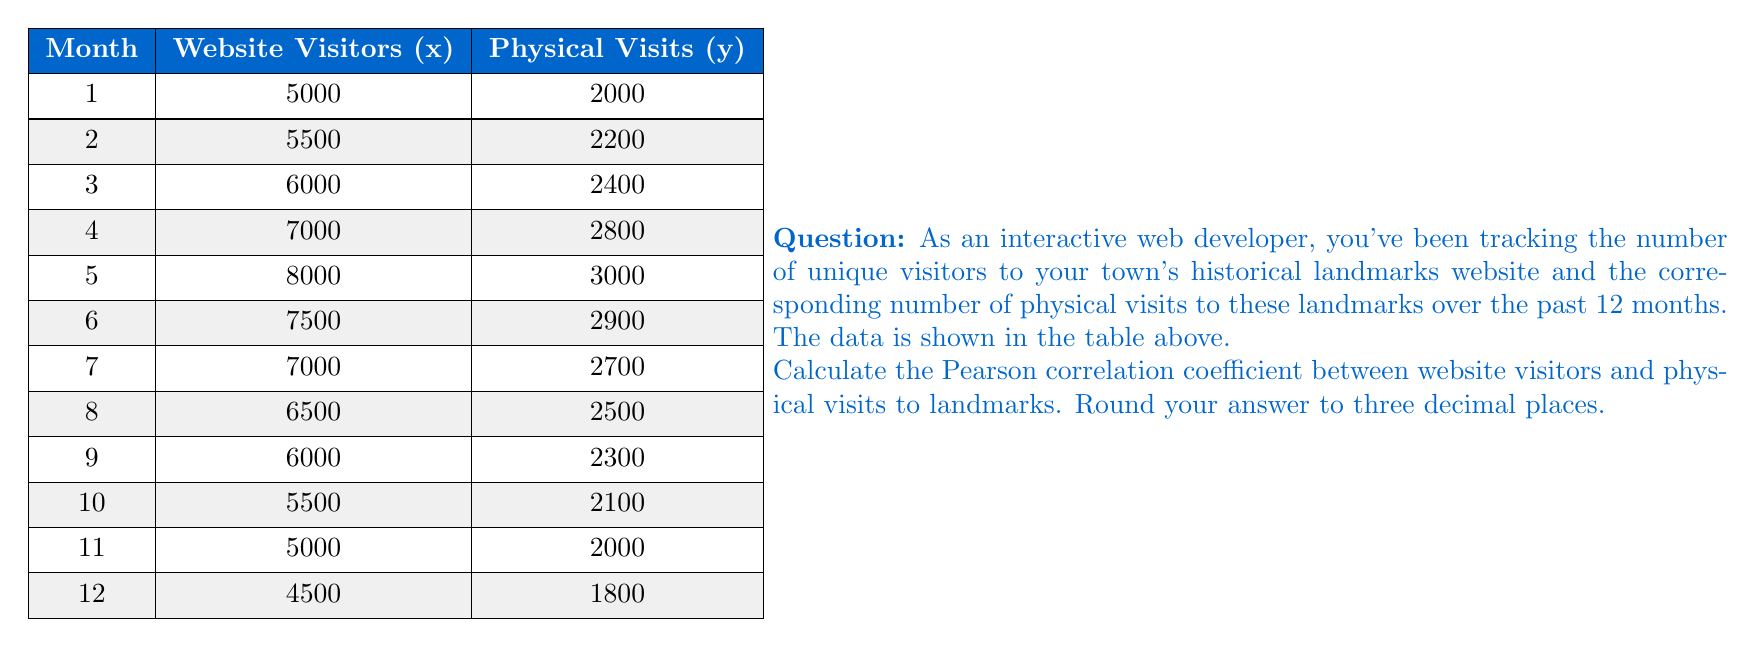Give your solution to this math problem. To calculate the Pearson correlation coefficient, we'll use the formula:

$$ r = \frac{\sum_{i=1}^{n} (x_i - \bar{x})(y_i - \bar{y})}{\sqrt{\sum_{i=1}^{n} (x_i - \bar{x})^2 \sum_{i=1}^{n} (y_i - \bar{y})^2}} $$

Where:
$x_i$ and $y_i$ are the individual sample points
$\bar{x}$ and $\bar{y}$ are the sample means
$n$ is the number of pairs of data

Step 1: Calculate the means
$\bar{x} = \frac{73500}{12} = 6125$
$\bar{y} = \frac{28700}{12} = 2391.67$

Step 2: Calculate $(x_i - \bar{x})$, $(y_i - \bar{y})$, $(x_i - \bar{x})^2$, $(y_i - \bar{y})^2$, and $(x_i - \bar{x})(y_i - \bar{y})$ for each pair

Step 3: Sum up the calculated values
$\sum (x_i - \bar{x})(y_i - \bar{y}) = 2,014,583.33$
$\sum (x_i - \bar{x})^2 = 13,239,583.33$
$\sum (y_i - \bar{y})^2 = 1,389,722.22$

Step 4: Apply the formula
$$ r = \frac{2,014,583.33}{\sqrt{13,239,583.33 \times 1,389,722.22}} $$

Step 5: Calculate and round to three decimal places
$r \approx 0.989$
Answer: 0.989 